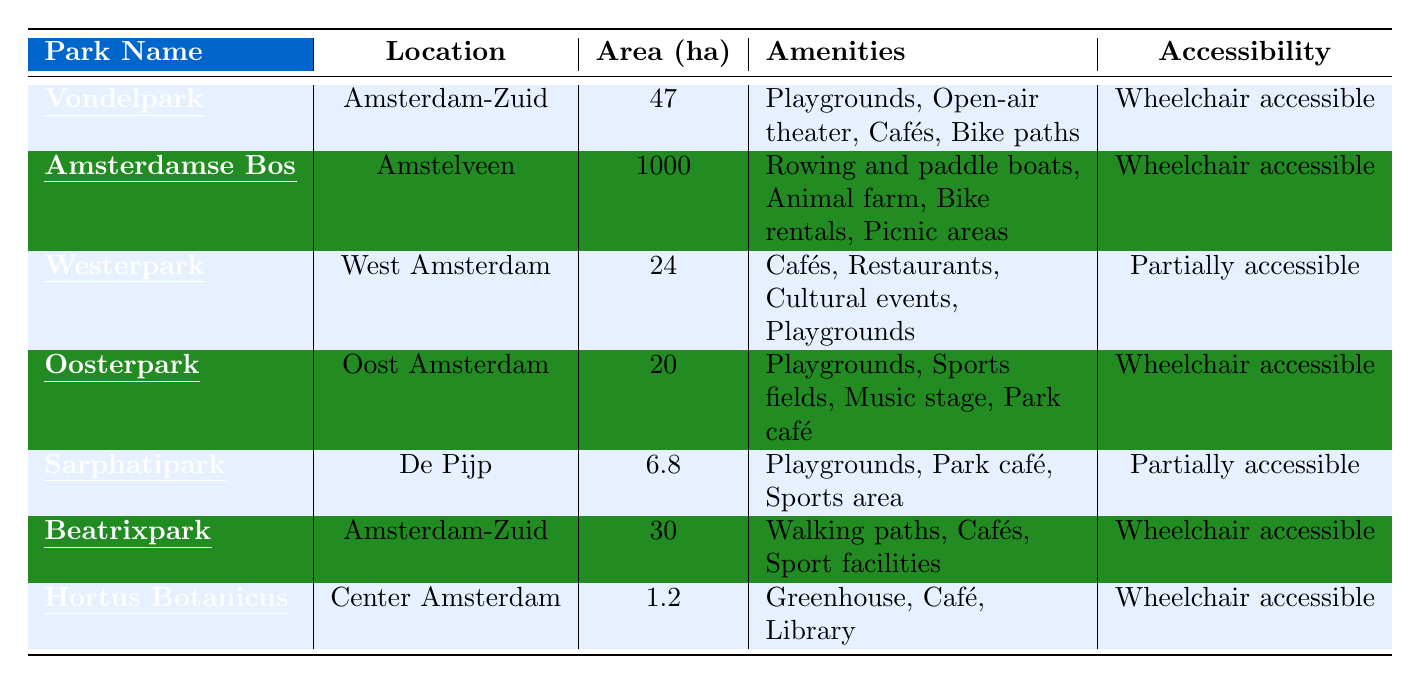What is the total area of all the parks listed? To find the total area, add the area of each park: 47 + 1000 + 24 + 20 + 6.8 + 30 + 1.2 = 1128
Answer: 1128 ha Which park has the most amenities? The park with the most amenities is Amsterdamse Bos, which has four different amenities listed: rowing and paddle boats, animal farm, bike rentals, and picnic areas, while others have fewer.
Answer: Amsterdamse Bos Is Oosterpark wheelchair accessible? Yes, the table indicates that Oosterpark is wheelchair accessible, confirming it has this feature.
Answer: Yes How many parks are in Amsterdam-Zuid? There are two parks located in Amsterdam-Zuid: Vondelpark and Beatrixpark, as can be seen from the location column.
Answer: 2 What is the difference in area between Amsterdamse Bos and Vondelpark? To find the difference, subtract the area of Vondelpark (47 ha) from Amsterdamse Bos (1000 ha): 1000 - 47 = 953.
Answer: 953 ha Which park features a historical fountain? Sarphatipark features a historical fountain, as indicated in the features column.
Answer: Sarphatipark What percentage of the total area is occupied by Vondelpark? To find the percentage, calculate (47 / 1128) * 100 ≈ 4.16%. This means Vondelpark occupies about 4.16% of the total area of the parks.
Answer: Approximately 4.16% Which parks are partially accessible? The table shows that Westerpark and Sarphatipark are partially accessible based on the accessibility column.
Answer: Westerpark and Sarphatipark How many parks have sports facilities listed among their amenities? Two parks, Oosterpark and Beatrixpark, have sports facilities listed as amenities.
Answer: 2 What are the features of the park that offers a library? The park with a library is Hortus Botanicus, which features diverse plant species and meditation areas.
Answer: Diverse plant species, meditation areas 